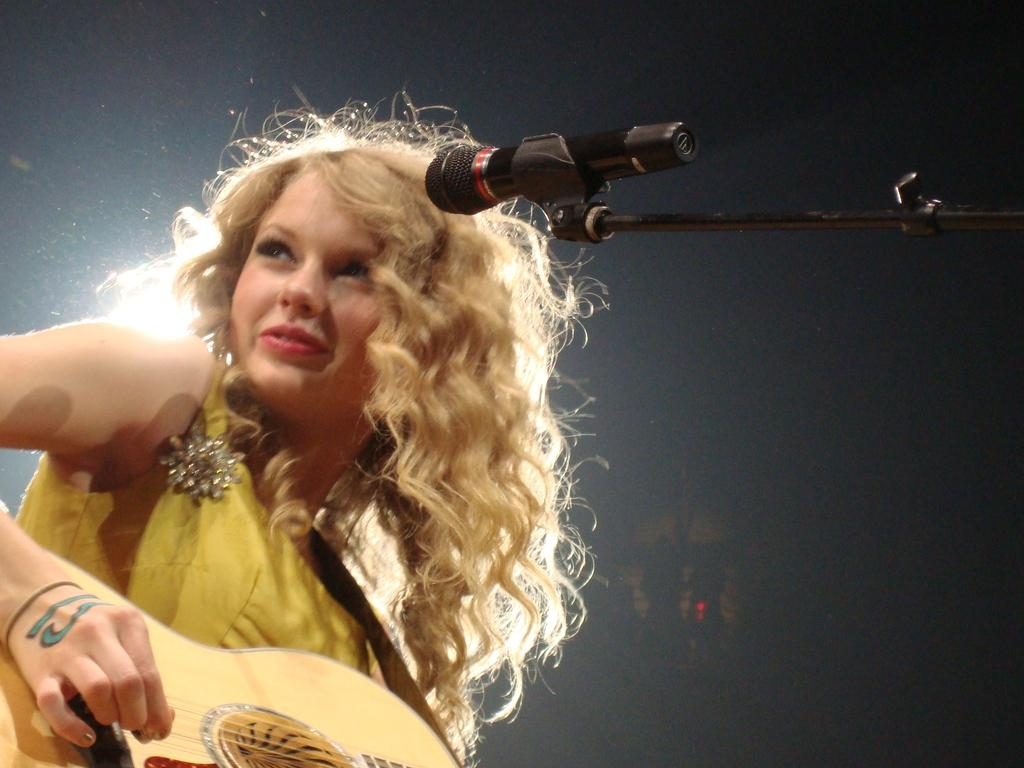Who is present in the image? There is a woman in the image. What is the woman wearing? The woman is wearing a yellow dress. What is the woman holding in the image? The woman is holding a guitar. What object can be seen on the right side of the image? There is a microphone on the right side of the image. What type of farm animals can be seen in the image? There are no farm animals present in the image. What time of day is it in the image? The time of day cannot be determined from the image. What is the woman eating for lunch in the image? There is no indication of food or lunch in the image. 